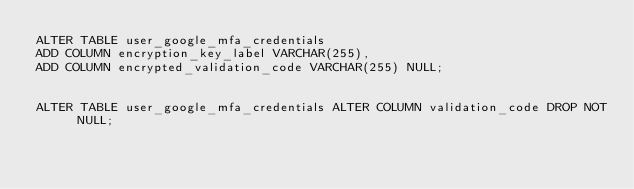Convert code to text. <code><loc_0><loc_0><loc_500><loc_500><_SQL_>ALTER TABLE user_google_mfa_credentials
ADD COLUMN encryption_key_label VARCHAR(255),
ADD COLUMN encrypted_validation_code VARCHAR(255) NULL;


ALTER TABLE user_google_mfa_credentials ALTER COLUMN validation_code DROP NOT NULL;</code> 